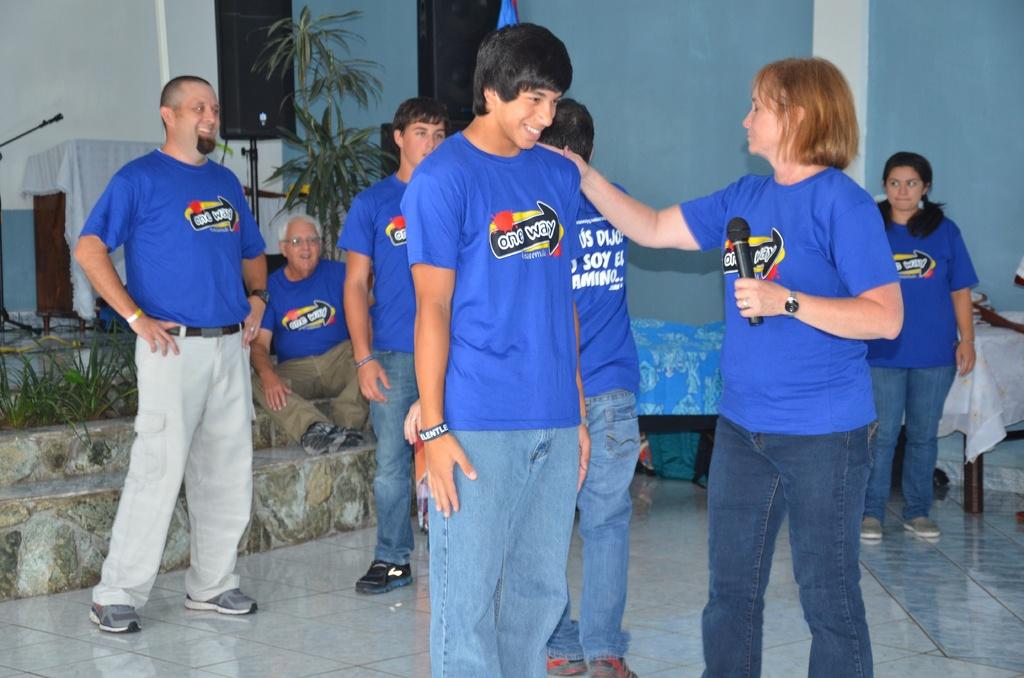Which way does the shirt tell you to go?
Offer a terse response. One way. 